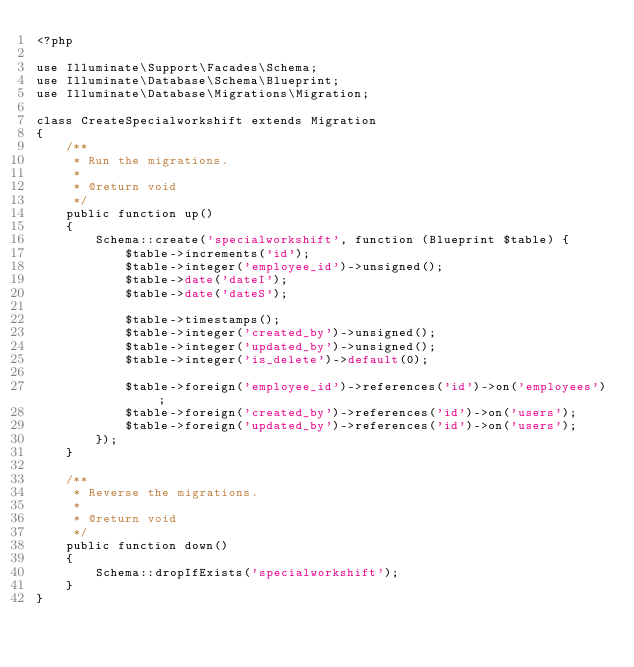<code> <loc_0><loc_0><loc_500><loc_500><_PHP_><?php

use Illuminate\Support\Facades\Schema;
use Illuminate\Database\Schema\Blueprint;
use Illuminate\Database\Migrations\Migration;

class CreateSpecialworkshift extends Migration
{
    /**
     * Run the migrations.
     *
     * @return void
     */
    public function up()
    {
        Schema::create('specialworkshift', function (Blueprint $table) {
            $table->increments('id');
            $table->integer('employee_id')->unsigned();
            $table->date('dateI');
            $table->date('dateS');

            $table->timestamps();
            $table->integer('created_by')->unsigned();
            $table->integer('updated_by')->unsigned();
            $table->integer('is_delete')->default(0);

            $table->foreign('employee_id')->references('id')->on('employees');
            $table->foreign('created_by')->references('id')->on('users');
            $table->foreign('updated_by')->references('id')->on('users');
        });
    }

    /**
     * Reverse the migrations.
     *
     * @return void
     */
    public function down()
    {
        Schema::dropIfExists('specialworkshift');
    }
}
</code> 